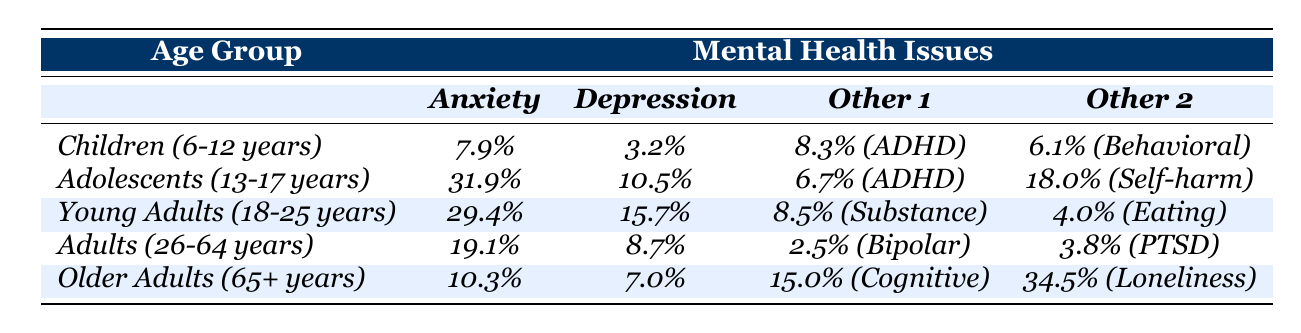What is the prevalence rate of anxiety disorders in adolescents (13-17 years)? The table shows that the prevalence rate of anxiety disorders in adolescents is listed as 31.9%.
Answer: 31.9% Which age group has the highest rate of depression? By comparing the depression rates across age groups, adolescents (10.5%) have the highest rate of depression, followed by young adults (15.7%).
Answer: Adolescents (10.5%) How many mental health issues are reported in children (6-12 years)? The table lists four mental health issues for children: anxiety disorders (7.9%), depression (3.2%), ADHD (8.3%), and behavioral problems (6.1%). Hence, there are 4 reported issues.
Answer: 4 What is the difference in the prevalence of anxiety disorders between young adults (18-25 years) and older adults (65+ years)? Young adults have an anxiety disorder rate of 29.4%, while older adults have a rate of 10.3%. The difference is calculated as 29.4% - 10.3% = 19.1%.
Answer: 19.1% Are the rates of cognitive impairment in older adults higher than those of ADHD in young adults? The table indicates that cognitive impairment in older adults is at 15.0%, while ADHD in young adults is at 8.3%. Therefore, the statement is true.
Answer: Yes What is the average prevalence rate of anxiety disorders across all age groups? The prevalence rates of anxiety disorders are: Children (7.9%), Adolescents (31.9%), Young Adults (29.4%), Adults (19.1%), and Older Adults (10.3%). The average is calculated as (7.9 + 31.9 + 29.4 + 19.1 + 10.3) / 5 = 19.72%.
Answer: 19.72% Which mental health issue has the highest reported prevalence in adolescents (13-17 years)? In the table, the mental health issues reported for adolescents are: anxiety disorders (31.9%), depression (10.5%), ADHD (6.7%), and self-harm (18.0%). The highest is anxiety disorders at 31.9%.
Answer: Anxiety disorders (31.9%) How do the rates of eating disorders compare between young adults and ADHD among children? Young adults have an eating disorder prevalence of 4.0%, while children have an ADHD prevalence of 8.3%. Comparing these figures shows that the ADHD rate in children is higher (8.3% > 4.0%).
Answer: ADHD is higher in children (8.3% vs 4.0%) What percentage of older adults report feelings of loneliness? The table states that the loneliness rate among older adults is 34.5%.
Answer: 34.5% What is the total prevalence rate of all reported mental health issues for young adults? Young adults have the following rates: anxiety disorders (29.4%), depression (15.7%), substance use disorders (8.5%), and eating disorders (4.0%). The total is computed as 29.4% + 15.7% + 8.5% + 4.0% = 57.6%.
Answer: 57.6% Is the prevalence rate of bipolar disorder in adults (26-64 years) higher than that of ADHD in children? The table shows bipolar disorder is at 2.5% for adults and ADHD is at 8.3% for children. Since 2.5% is less than 8.3%, the statement is false.
Answer: No 